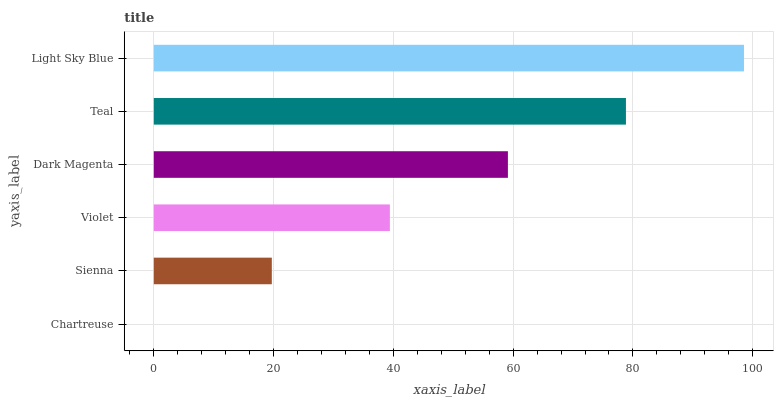Is Chartreuse the minimum?
Answer yes or no. Yes. Is Light Sky Blue the maximum?
Answer yes or no. Yes. Is Sienna the minimum?
Answer yes or no. No. Is Sienna the maximum?
Answer yes or no. No. Is Sienna greater than Chartreuse?
Answer yes or no. Yes. Is Chartreuse less than Sienna?
Answer yes or no. Yes. Is Chartreuse greater than Sienna?
Answer yes or no. No. Is Sienna less than Chartreuse?
Answer yes or no. No. Is Dark Magenta the high median?
Answer yes or no. Yes. Is Violet the low median?
Answer yes or no. Yes. Is Sienna the high median?
Answer yes or no. No. Is Teal the low median?
Answer yes or no. No. 